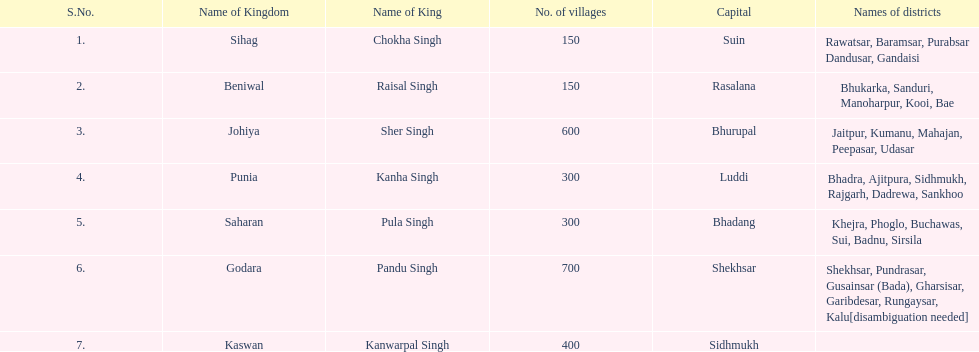What is the number of kingdoms that have more than 300 villages? 3. 